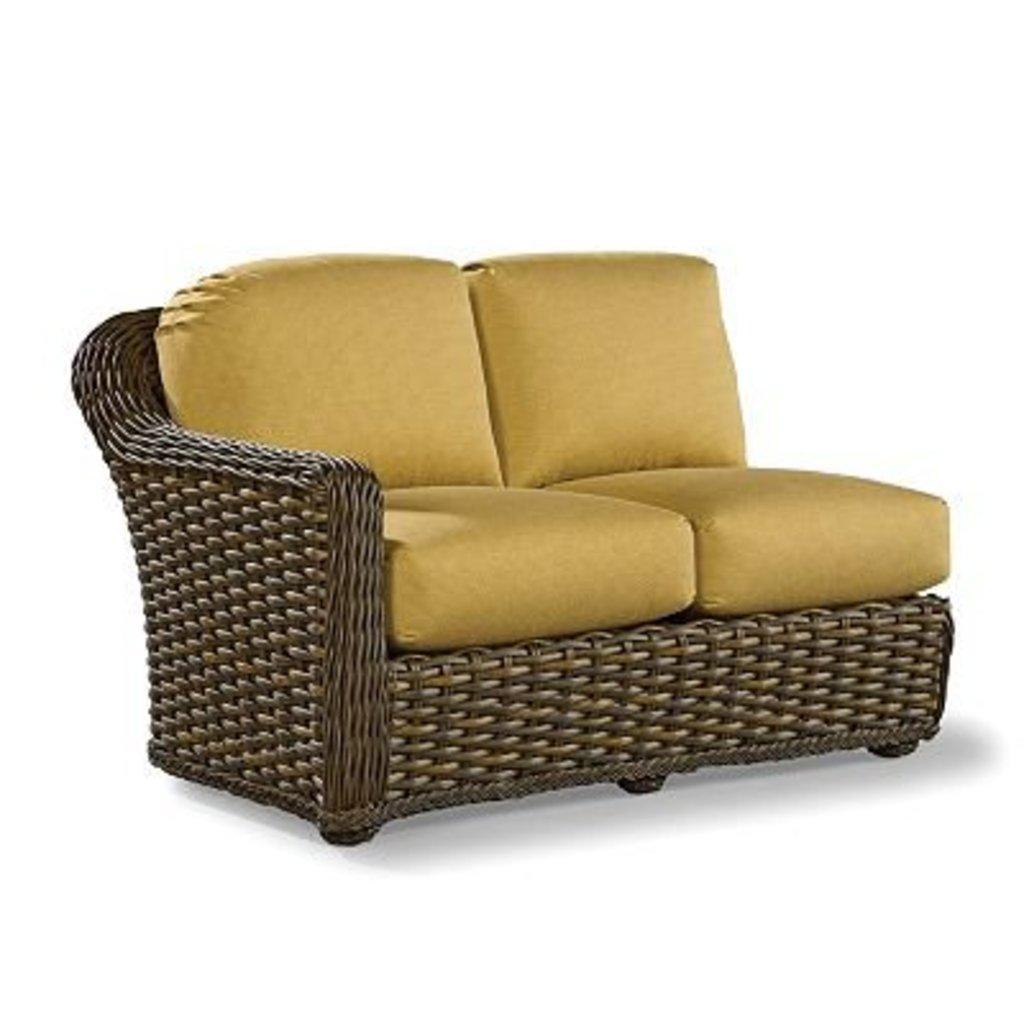In one or two sentences, can you explain what this image depicts? In this image we can see a sofa. The background of the image is white in colour. 